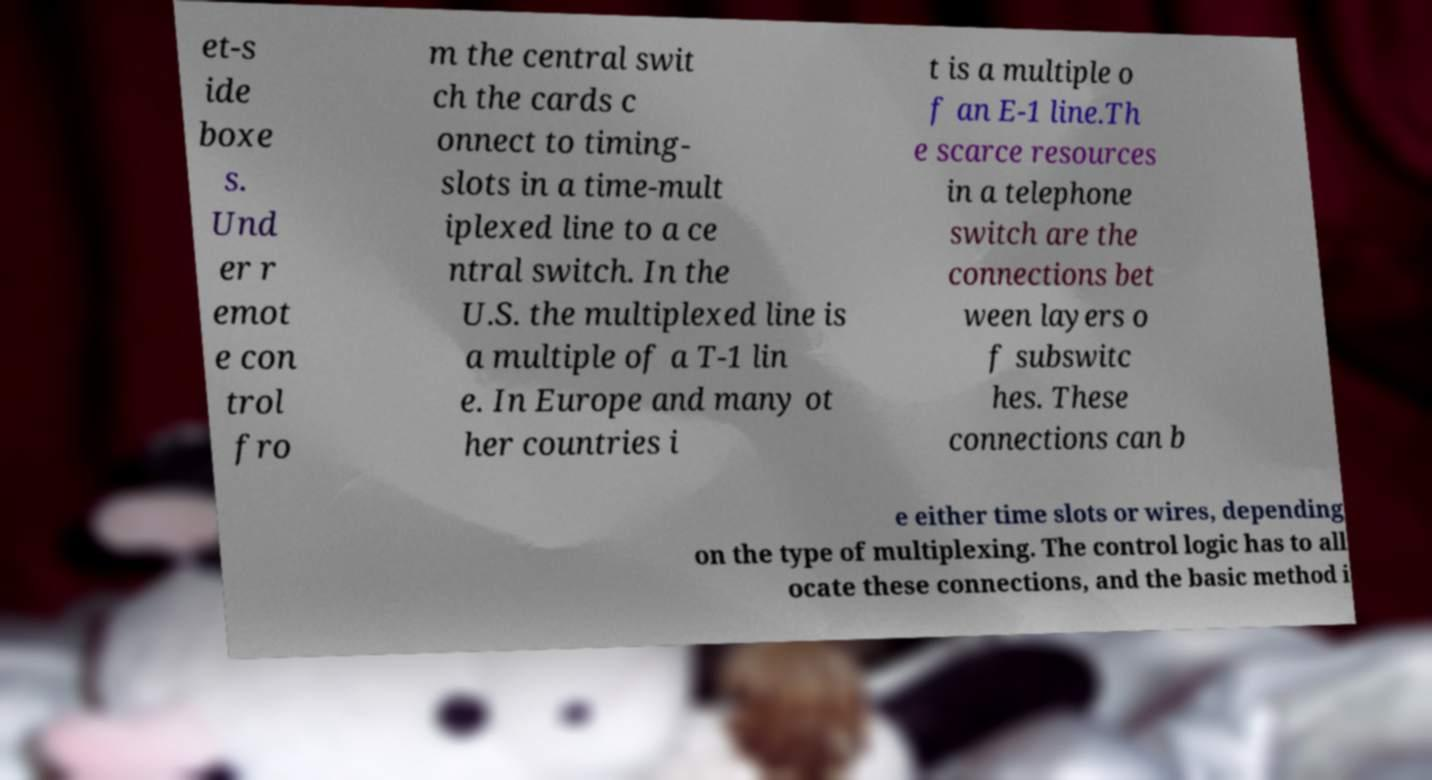Can you read and provide the text displayed in the image?This photo seems to have some interesting text. Can you extract and type it out for me? et-s ide boxe s. Und er r emot e con trol fro m the central swit ch the cards c onnect to timing- slots in a time-mult iplexed line to a ce ntral switch. In the U.S. the multiplexed line is a multiple of a T-1 lin e. In Europe and many ot her countries i t is a multiple o f an E-1 line.Th e scarce resources in a telephone switch are the connections bet ween layers o f subswitc hes. These connections can b e either time slots or wires, depending on the type of multiplexing. The control logic has to all ocate these connections, and the basic method i 